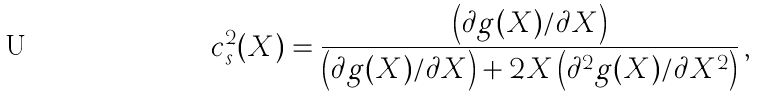<formula> <loc_0><loc_0><loc_500><loc_500>c _ { s } ^ { 2 } ( X ) = \frac { \left ( \partial g ( X ) / \partial X \right ) } { \left ( \partial g ( X ) / \partial X \right ) + 2 X \left ( \partial ^ { 2 } g ( X ) / \partial X ^ { 2 } \right ) } \, ,</formula> 